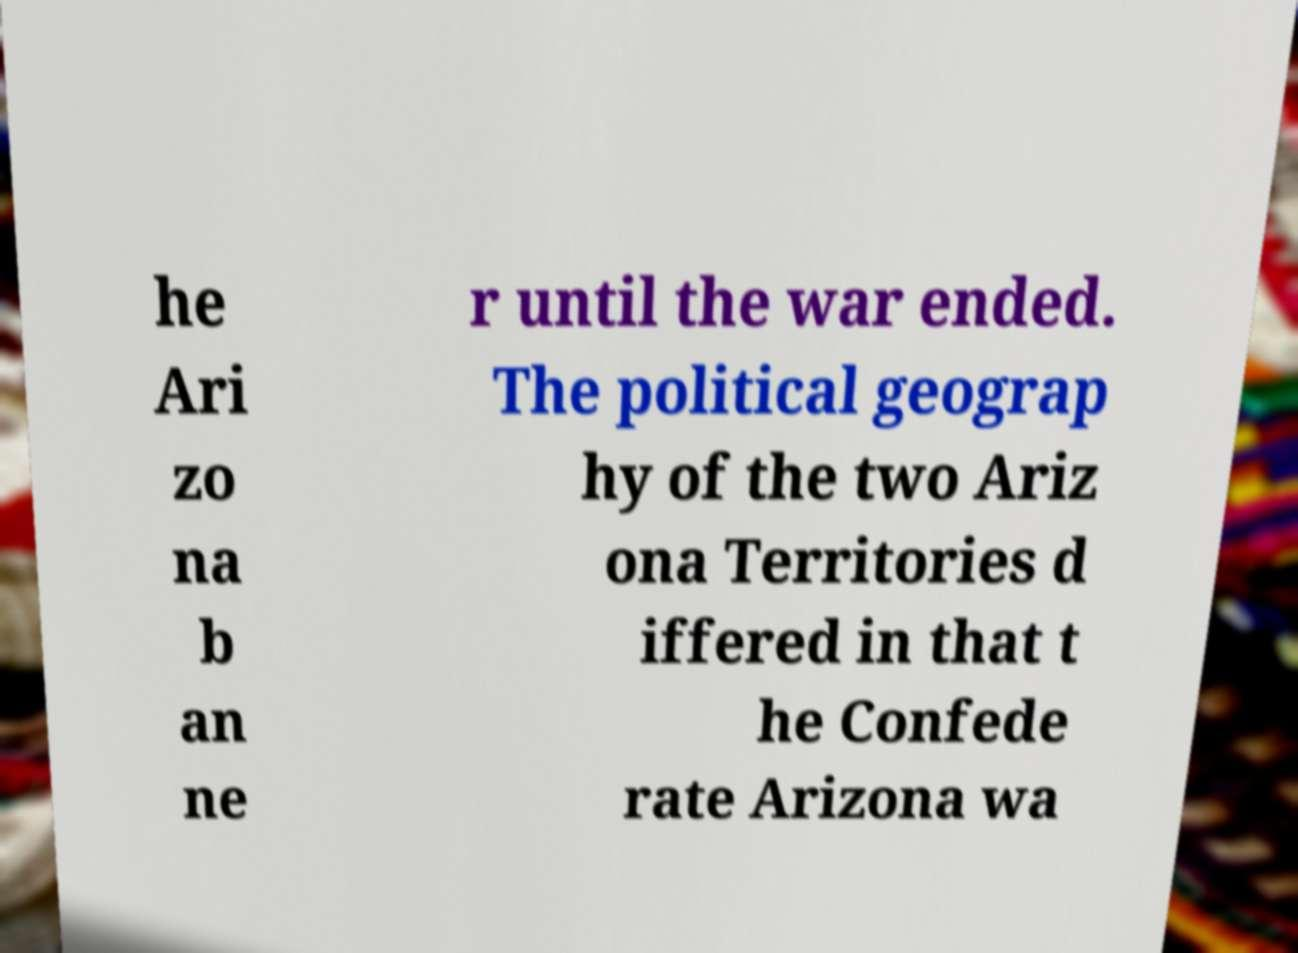Can you accurately transcribe the text from the provided image for me? he Ari zo na b an ne r until the war ended. The political geograp hy of the two Ariz ona Territories d iffered in that t he Confede rate Arizona wa 